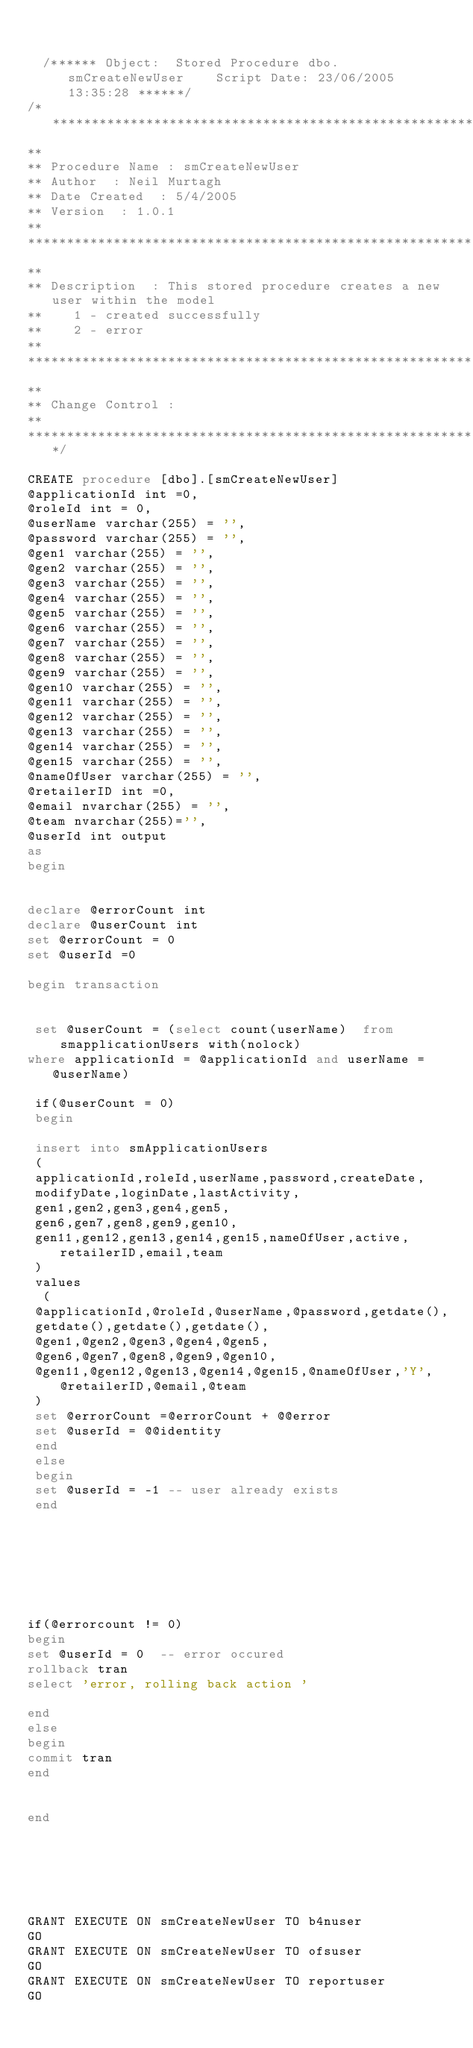<code> <loc_0><loc_0><loc_500><loc_500><_SQL_>

  /****** Object:  Stored Procedure dbo.smCreateNewUser    Script Date: 23/06/2005 13:35:28 ******/  
/*********************************************************************************************************************  
**                       
** Procedure Name : smCreateNewUser  
** Author  : Neil Murtagh   
** Date Created  : 5/4/2005  
** Version  : 1.0.1  
**       
**********************************************************************************************************************  
**      
** Description  : This stored procedure creates a new user within the model  
**    1 - created successfully  
**    2 - error  
**       
**********************************************************************************************************************  
**           
** Change Control :   
**        
**********************************************************************************************************************/  
         
CREATE procedure [dbo].[smCreateNewUser]  
@applicationId int =0,  
@roleId int = 0,  
@userName varchar(255) = '',  
@password varchar(255) = '',  
@gen1 varchar(255) = '',  
@gen2 varchar(255) = '',  
@gen3 varchar(255) = '',  
@gen4 varchar(255) = '',  
@gen5 varchar(255) = '',  
@gen6 varchar(255) = '',  
@gen7 varchar(255) = '',  
@gen8 varchar(255) = '',  
@gen9 varchar(255) = '',  
@gen10 varchar(255) = '',  
@gen11 varchar(255) = '',  
@gen12 varchar(255) = '',  
@gen13 varchar(255) = '',  
@gen14 varchar(255) = '',  
@gen15 varchar(255) = '',  
@nameOfUser varchar(255) = '',  
@retailerID int =0,
@email nvarchar(255) = '',
@team nvarchar(255)='',
@userId int output
as  
begin  
  
  
declare @errorCount int  
declare @userCount int  
set @errorCount = 0  
set @userId =0  
  
begin transaction  
  
  
 set @userCount = (select count(userName)  from smapplicationUsers with(nolock)  
where applicationId = @applicationId and userName = @userName)  
  
 if(@userCount = 0)  
 begin  
  
 insert into smApplicationUsers  
 (  
 applicationId,roleId,userName,password,createDate,  
 modifyDate,loginDate,lastActivity,  
 gen1,gen2,gen3,gen4,gen5,  
 gen6,gen7,gen8,gen9,gen10,  
 gen11,gen12,gen13,gen14,gen15,nameOfUser,active,retailerID,email,team  
 )  
 values  
  (  
 @applicationId,@roleId,@userName,@password,getdate(),  
 getdate(),getdate(),getdate(),  
 @gen1,@gen2,@gen3,@gen4,@gen5,  
 @gen6,@gen7,@gen8,@gen9,@gen10,  
 @gen11,@gen12,@gen13,@gen14,@gen15,@nameOfUser,'Y',@retailerID,@email,@team  
 )  
 set @errorCount =@errorCount + @@error   
 set @userId = @@identity  
 end  
 else  
 begin  
 set @userId = -1 -- user already exists  
 end  
   
  
   
  
   
  
  
if(@errorcount != 0)  
begin  
set @userId = 0  -- error occured  
rollback tran  
select 'error, rolling back action '  
  
end  
else  
begin  
commit tran  
end  
  
  
end  
  
  
  
  
  

GRANT EXECUTE ON smCreateNewUser TO b4nuser
GO
GRANT EXECUTE ON smCreateNewUser TO ofsuser
GO
GRANT EXECUTE ON smCreateNewUser TO reportuser
GO
</code> 